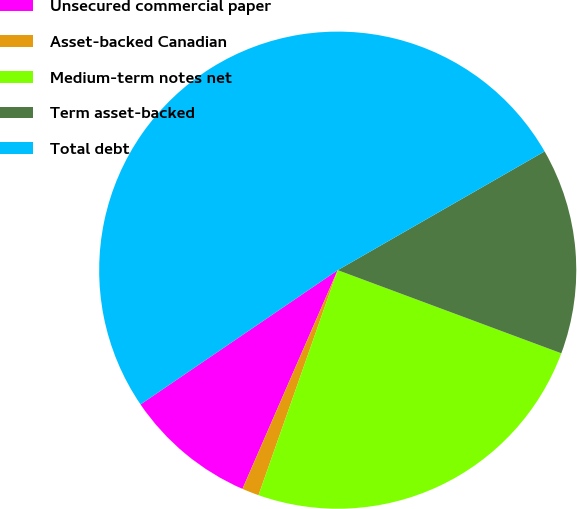Convert chart to OTSL. <chart><loc_0><loc_0><loc_500><loc_500><pie_chart><fcel>Unsecured commercial paper<fcel>Asset-backed Canadian<fcel>Medium-term notes net<fcel>Term asset-backed<fcel>Total debt<nl><fcel>8.95%<fcel>1.15%<fcel>24.72%<fcel>13.96%<fcel>51.22%<nl></chart> 